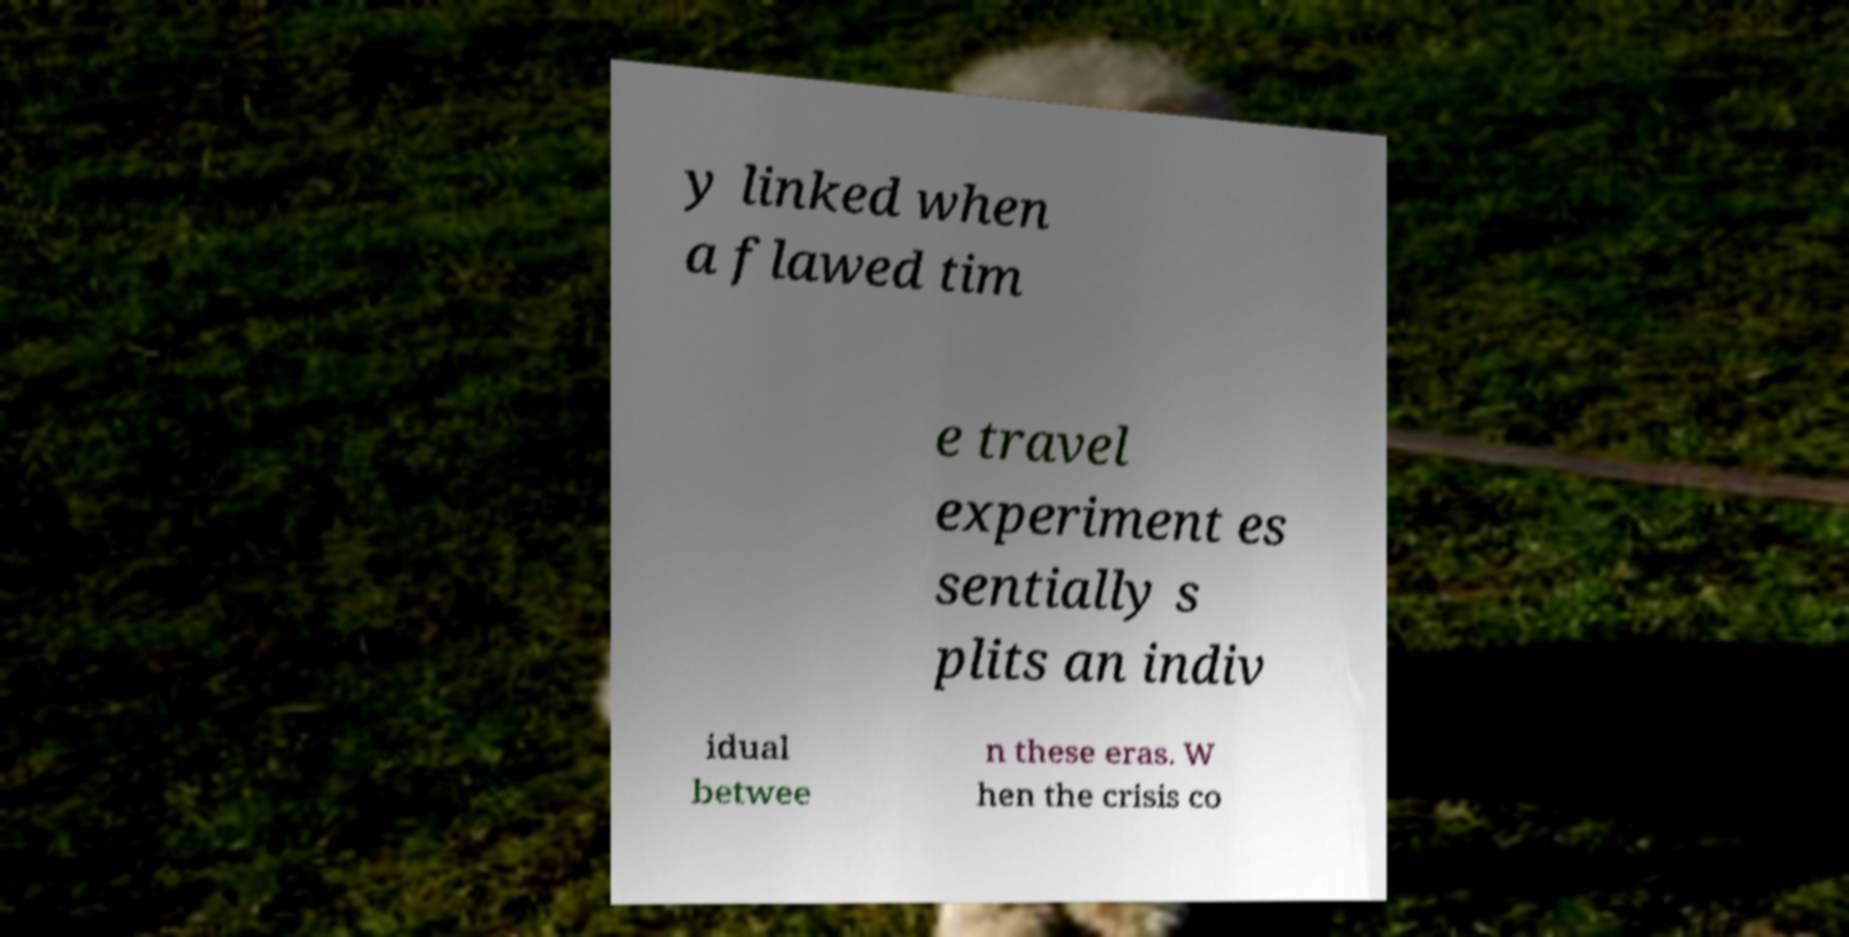Could you extract and type out the text from this image? y linked when a flawed tim e travel experiment es sentially s plits an indiv idual betwee n these eras. W hen the crisis co 